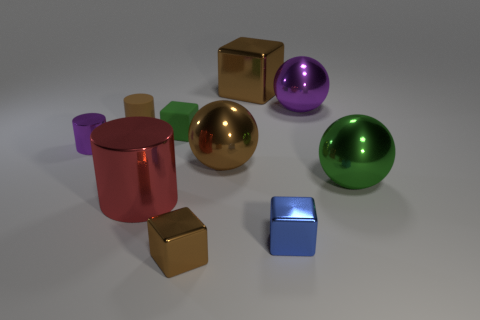Does the small matte thing on the left side of the large cylinder have the same color as the big cube?
Ensure brevity in your answer.  Yes. There is a shiny cylinder that is behind the big green shiny object; are there any brown metal things behind it?
Offer a very short reply. Yes. What is the material of the big sphere that is behind the green metal sphere and to the right of the small blue cube?
Make the answer very short. Metal. The tiny purple object that is made of the same material as the big brown sphere is what shape?
Your response must be concise. Cylinder. Is there anything else that is the same shape as the big red thing?
Make the answer very short. Yes. Is the small thing to the right of the tiny brown metal object made of the same material as the big purple sphere?
Offer a very short reply. Yes. There is a large thing that is left of the green block; what is it made of?
Make the answer very short. Metal. How big is the green sphere behind the metal block that is in front of the tiny blue cube?
Make the answer very short. Large. How many other cylinders have the same size as the purple cylinder?
Make the answer very short. 1. There is a large ball that is behind the matte cube; is it the same color as the shiny cylinder behind the green metal thing?
Your response must be concise. Yes. 